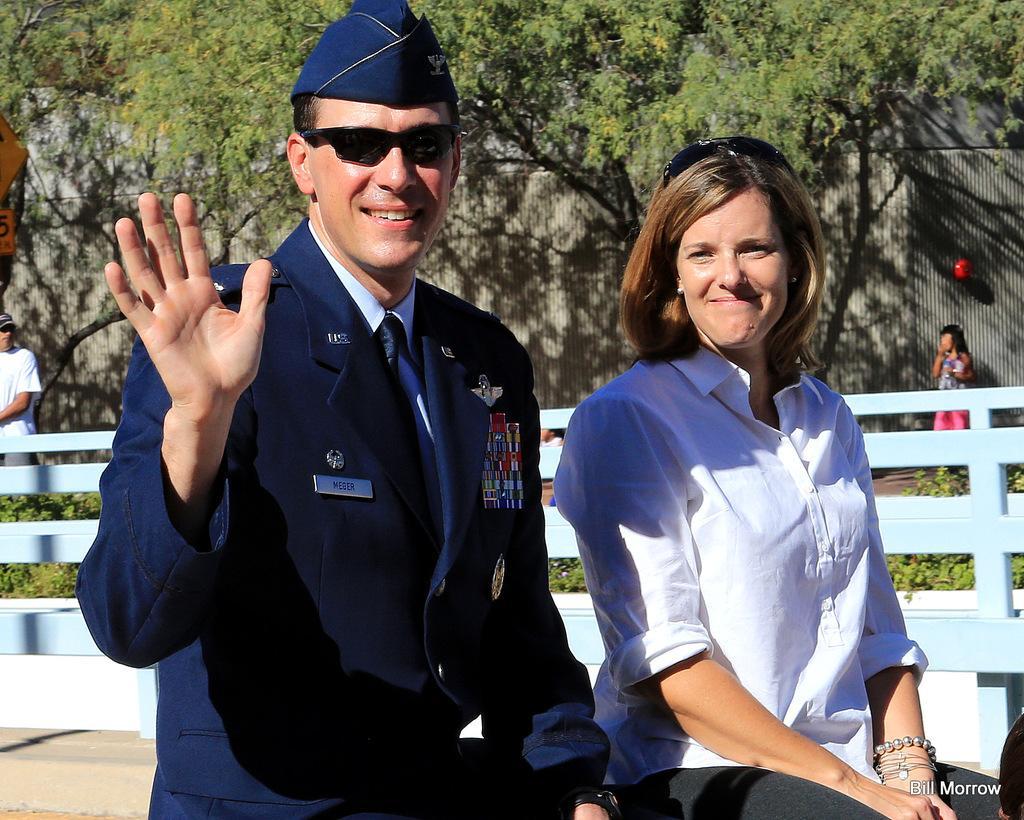How would you summarize this image in a sentence or two? In the image there are two people and behind them there is a fence, behind the fence there are few trees and two other people. 